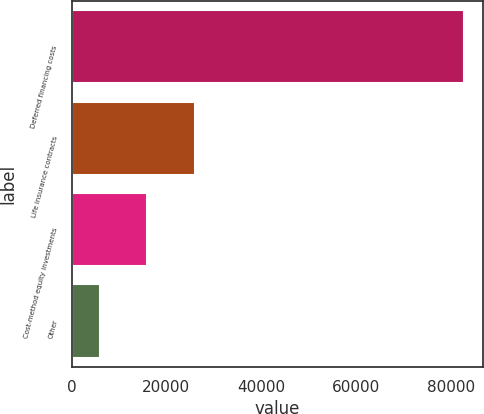Convert chart. <chart><loc_0><loc_0><loc_500><loc_500><bar_chart><fcel>Deferred financing costs<fcel>Life insurance contracts<fcel>Cost-method equity investments<fcel>Other<nl><fcel>82760<fcel>25978<fcel>15976<fcel>6006<nl></chart> 